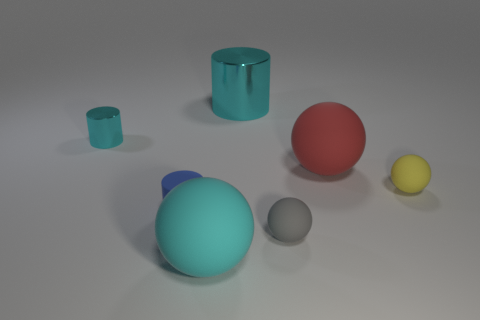Subtract 1 balls. How many balls are left? 3 Add 3 cyan rubber objects. How many objects exist? 10 Subtract all cylinders. How many objects are left? 4 Subtract all large cyan metal cubes. Subtract all tiny yellow rubber balls. How many objects are left? 6 Add 4 red rubber balls. How many red rubber balls are left? 5 Add 4 small gray spheres. How many small gray spheres exist? 5 Subtract 0 blue cubes. How many objects are left? 7 